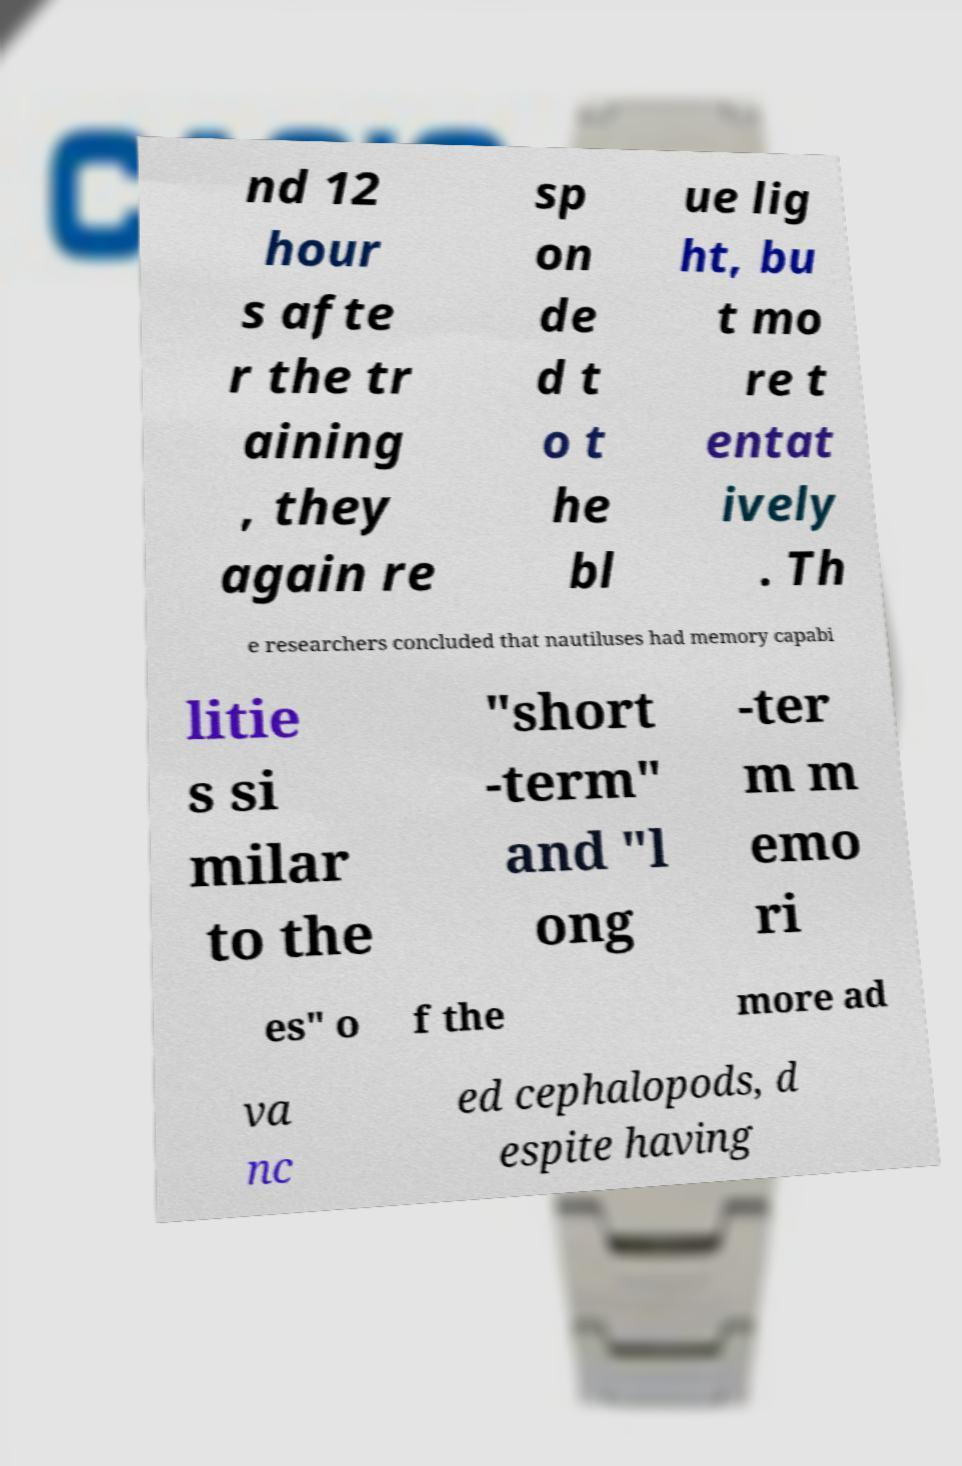Can you read and provide the text displayed in the image?This photo seems to have some interesting text. Can you extract and type it out for me? nd 12 hour s afte r the tr aining , they again re sp on de d t o t he bl ue lig ht, bu t mo re t entat ively . Th e researchers concluded that nautiluses had memory capabi litie s si milar to the "short -term" and "l ong -ter m m emo ri es" o f the more ad va nc ed cephalopods, d espite having 